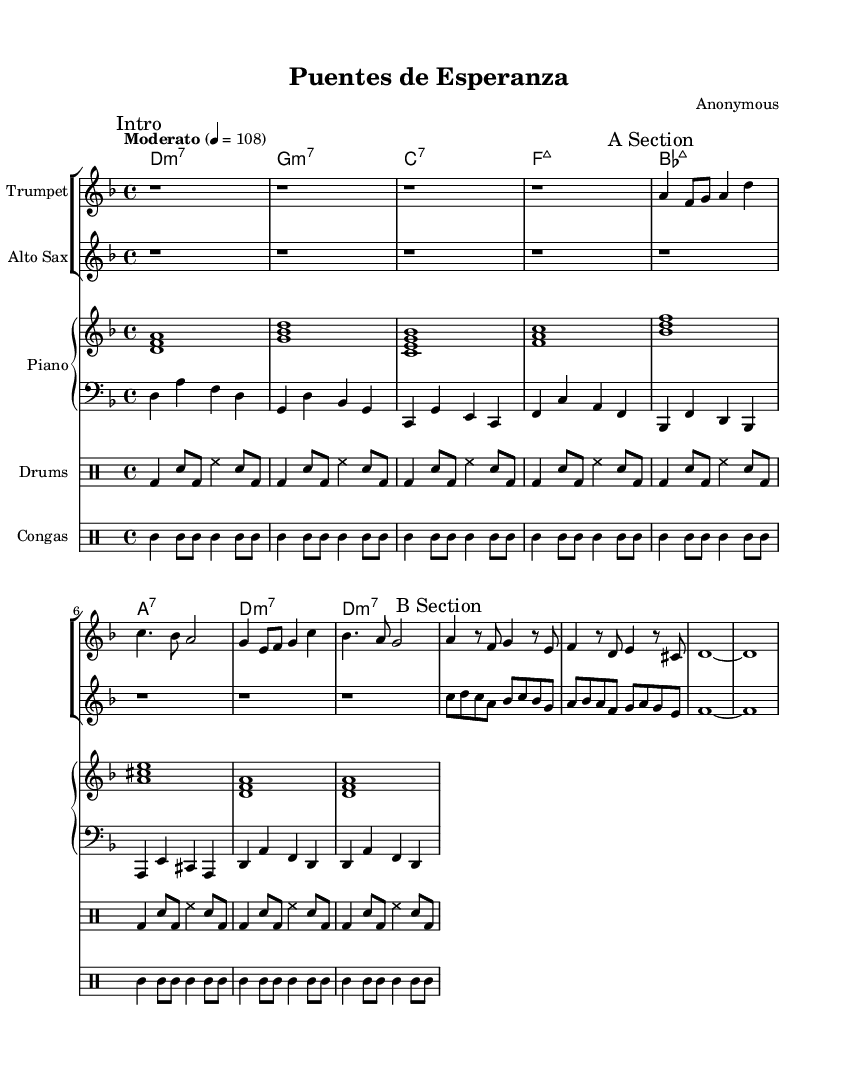What is the key signature of this music? The key signature is indicated at the beginning of the score; it shows two flat symbols, which means the key is D minor.
Answer: D minor What is the time signature of this piece? The time signature is written at the beginning of the score with the numbers 4 and 4 stacked on top of each other, indicating that there are four beats per measure.
Answer: 4/4 What is the tempo marking given in the score? The tempo marking is found in the header section of the score and indicates a moderate speed of 108 beats per minute.
Answer: Moderato 4 = 108 How many measures are in the A Section? The A Section is indicated in the score, and the trumpet part shows a total of 8 measures. Each measure can be counted visually.
Answer: 8 What is the chord progression in the first four measures? The chord progression is identified from the chord names written below the staff, showing D minor 7, G minor 7, C7, and F major 7 in the first four measures.
Answer: D minor 7, G minor 7, C7, F major 7 Which instruments are playing the melody in this piece? The melody is typically carried by solo instruments, in this score, the trumpet and alto saxophone are indicated as playing the melody lines.
Answer: Trumpet, Alto Saxophone Identify the rhythm pattern used in the drums. The rhythm pattern is observed through the drum notation, where kick drum (bd), snare (sn), and hi-hat (hh) are arranged in a specific sequence representing a repetitive 4/4 pattern.
Answer: Rhythmic variation in 4/4 